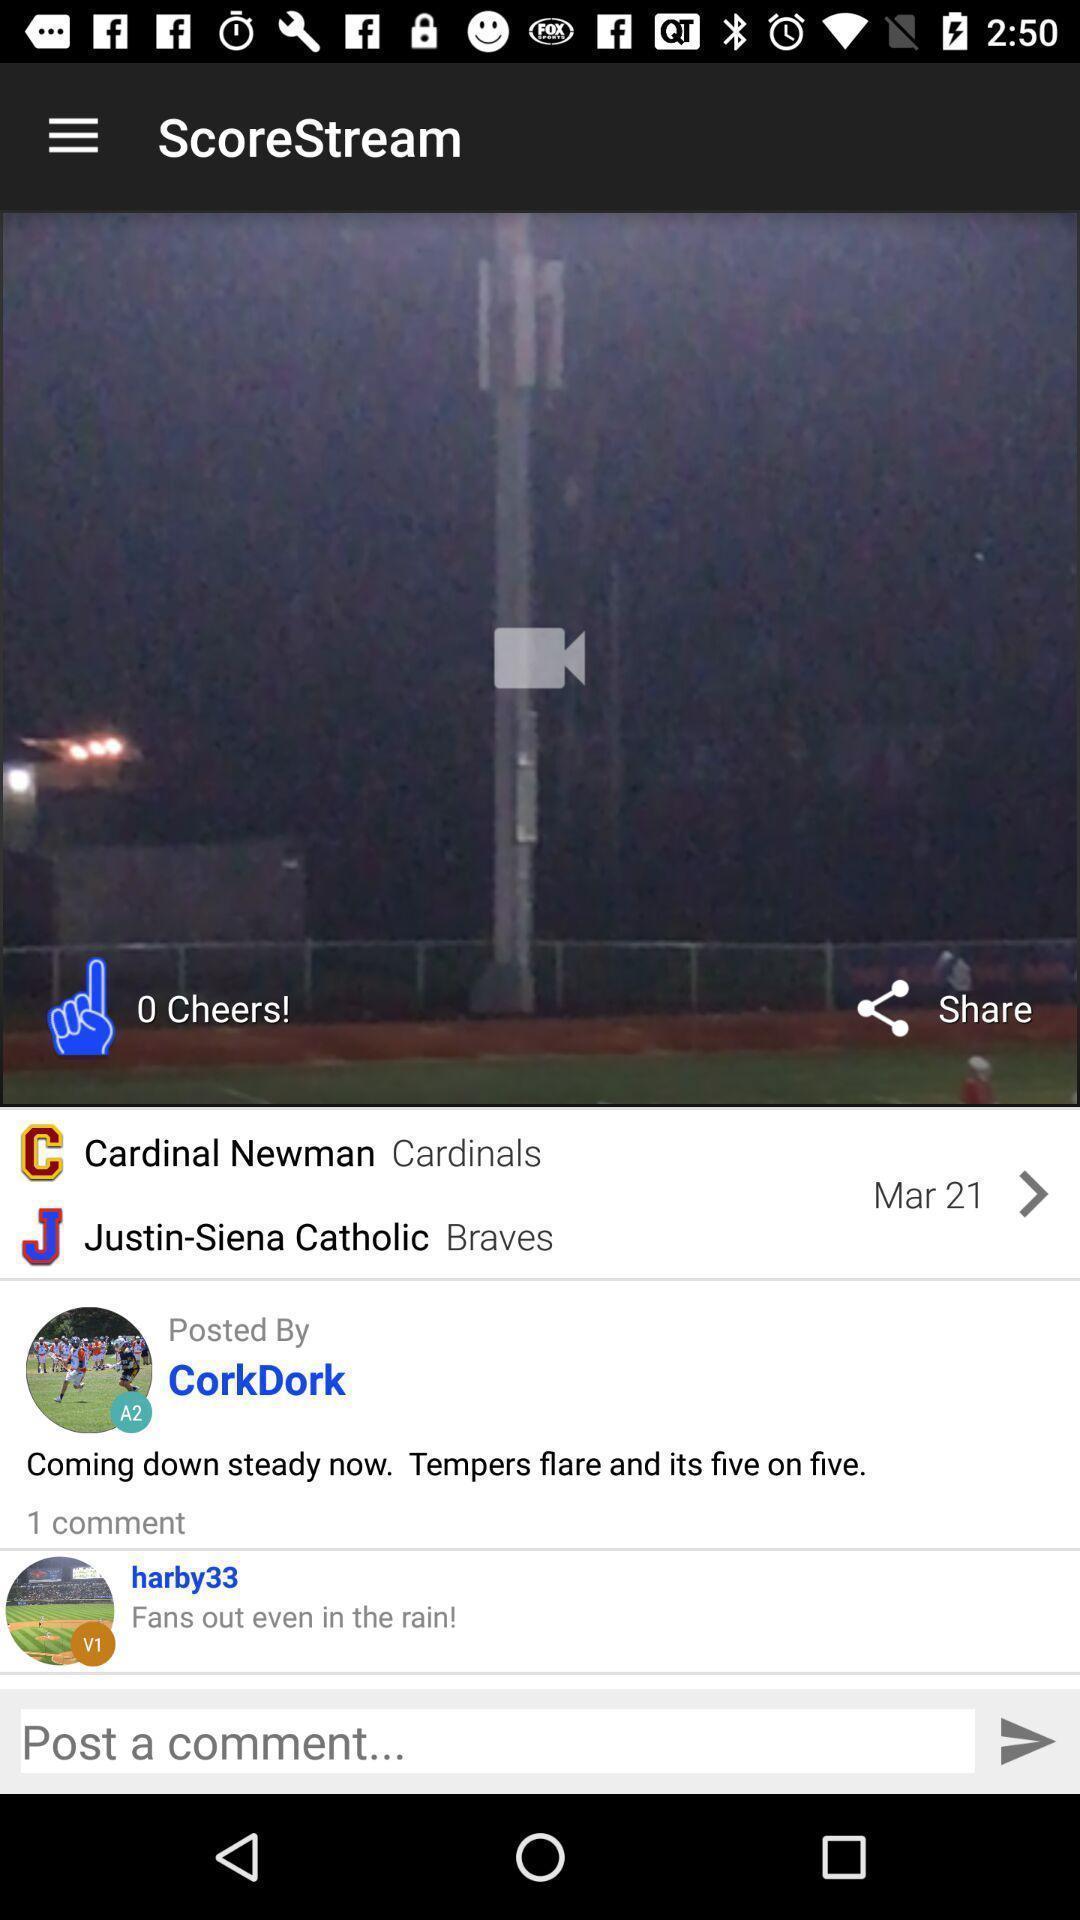Summarize the main components in this picture. Screen displaying the viewers comments. 